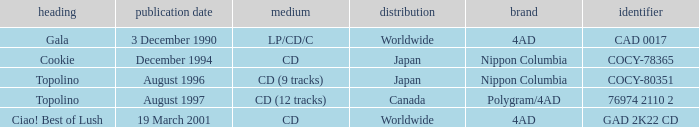What format was released in August 1996? CD (9 tracks). 